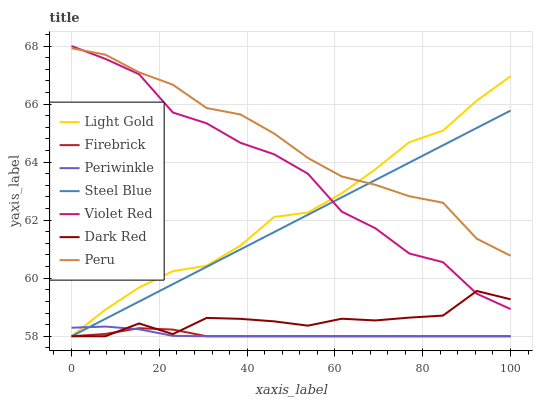Does Firebrick have the minimum area under the curve?
Answer yes or no. Yes. Does Peru have the maximum area under the curve?
Answer yes or no. Yes. Does Dark Red have the minimum area under the curve?
Answer yes or no. No. Does Dark Red have the maximum area under the curve?
Answer yes or no. No. Is Steel Blue the smoothest?
Answer yes or no. Yes. Is Violet Red the roughest?
Answer yes or no. Yes. Is Dark Red the smoothest?
Answer yes or no. No. Is Dark Red the roughest?
Answer yes or no. No. Does Dark Red have the lowest value?
Answer yes or no. Yes. Does Peru have the lowest value?
Answer yes or no. No. Does Violet Red have the highest value?
Answer yes or no. Yes. Does Dark Red have the highest value?
Answer yes or no. No. Is Periwinkle less than Violet Red?
Answer yes or no. Yes. Is Violet Red greater than Periwinkle?
Answer yes or no. Yes. Does Periwinkle intersect Firebrick?
Answer yes or no. Yes. Is Periwinkle less than Firebrick?
Answer yes or no. No. Is Periwinkle greater than Firebrick?
Answer yes or no. No. Does Periwinkle intersect Violet Red?
Answer yes or no. No. 